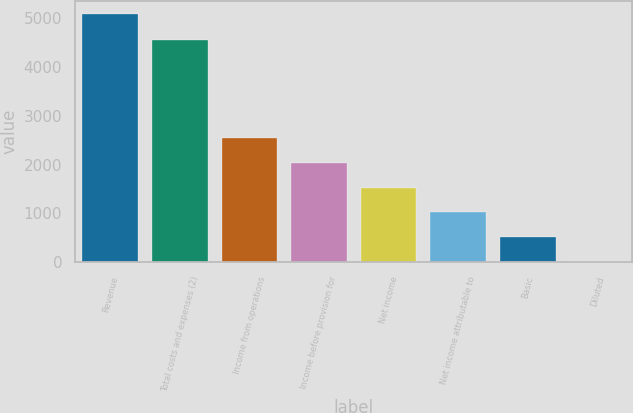Convert chart to OTSL. <chart><loc_0><loc_0><loc_500><loc_500><bar_chart><fcel>Revenue<fcel>Total costs and expenses (2)<fcel>Income from operations<fcel>Income before provision for<fcel>Net income<fcel>Net income attributable to<fcel>Basic<fcel>Diluted<nl><fcel>5089<fcel>4551<fcel>2544.51<fcel>2035.61<fcel>1526.71<fcel>1017.81<fcel>508.91<fcel>0.01<nl></chart> 